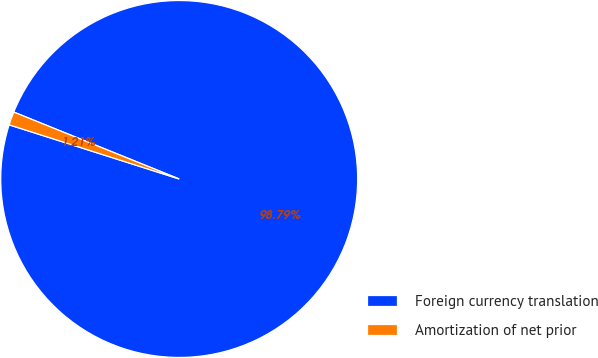Convert chart. <chart><loc_0><loc_0><loc_500><loc_500><pie_chart><fcel>Foreign currency translation<fcel>Amortization of net prior<nl><fcel>98.79%<fcel>1.21%<nl></chart> 